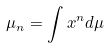Convert formula to latex. <formula><loc_0><loc_0><loc_500><loc_500>\mu _ { n } = \int x ^ { n } d \mu</formula> 